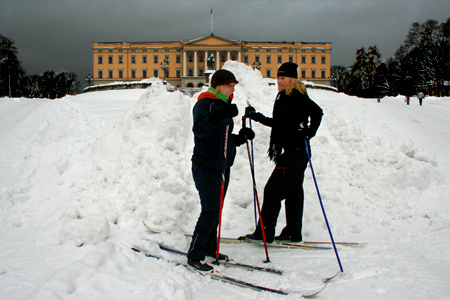Which color is the girl cap? The girl's cap is black. 